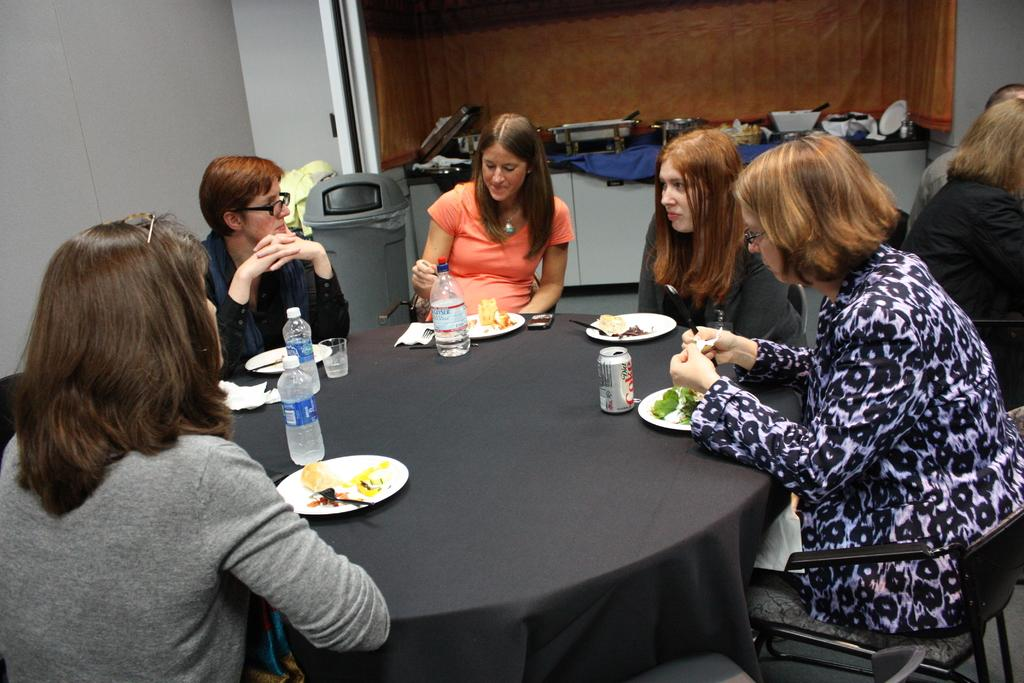What are the people in the image doing? The group of people is sitting on chairs. What is on the table in the image? There is a plate, a spoon, a bottle, a cup, and food on the table. Can you describe the table setting in the image? The table has a plate, a spoon, a bottle, a cup, and food on it. Is there any waste disposal visible in the image? Yes, there is a bin at the back side of the image. What type of wound can be seen on the toe of the person sitting on the left chair? There is no person sitting on the left chair, and no wound or toe is visible in the image. What type of knife is being used by the person sitting on the right chair? There is no knife present in the image, and no person is sitting on the right chair. 